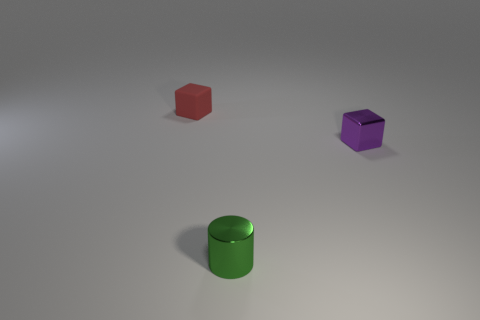The purple thing that is the same material as the green cylinder is what shape?
Provide a succinct answer. Cube. Is the size of the purple object right of the cylinder the same as the tiny red cube?
Your answer should be compact. Yes. What shape is the tiny metallic object that is in front of the block that is in front of the tiny red rubber cube?
Keep it short and to the point. Cylinder. There is a metallic thing in front of the small cube in front of the tiny matte block; what size is it?
Provide a short and direct response. Small. What is the color of the block that is on the right side of the tiny red matte block?
Ensure brevity in your answer.  Purple. How many other tiny objects have the same shape as the purple metallic object?
Provide a succinct answer. 1. There is a purple cube that is the same size as the cylinder; what is its material?
Give a very brief answer. Metal. Is there another green cylinder that has the same material as the tiny green cylinder?
Your response must be concise. No. What color is the tiny object that is left of the shiny cube and behind the tiny green cylinder?
Ensure brevity in your answer.  Red. What number of other objects are there of the same color as the metal block?
Ensure brevity in your answer.  0. 